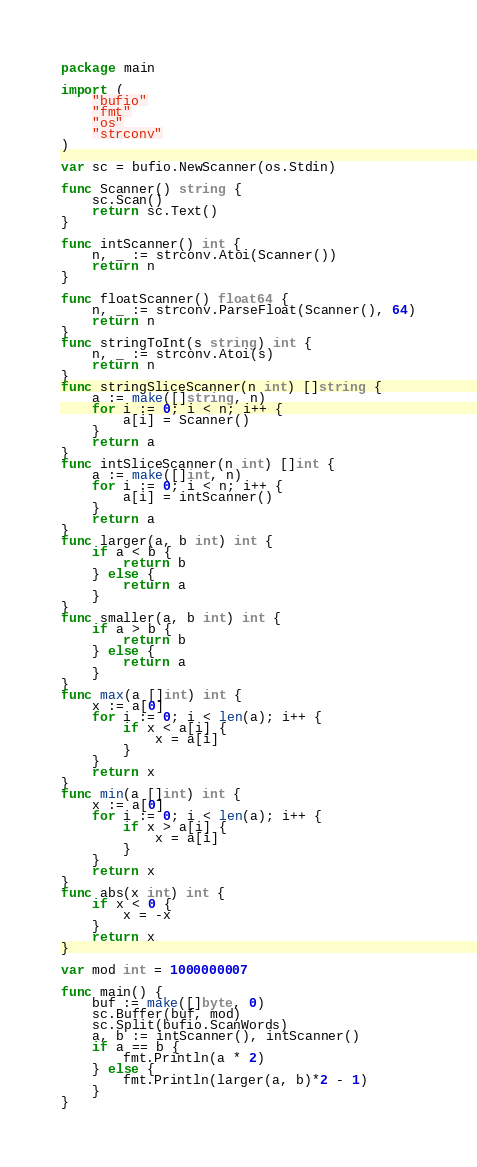<code> <loc_0><loc_0><loc_500><loc_500><_Go_>package main

import (
	"bufio"
	"fmt"
	"os"
	"strconv"
)

var sc = bufio.NewScanner(os.Stdin)

func Scanner() string {
	sc.Scan()
	return sc.Text()
}

func intScanner() int {
	n, _ := strconv.Atoi(Scanner())
	return n
}

func floatScanner() float64 {
	n, _ := strconv.ParseFloat(Scanner(), 64)
	return n
}
func stringToInt(s string) int {
	n, _ := strconv.Atoi(s)
	return n
}
func stringSliceScanner(n int) []string {
	a := make([]string, n)
	for i := 0; i < n; i++ {
		a[i] = Scanner()
	}
	return a
}
func intSliceScanner(n int) []int {
	a := make([]int, n)
	for i := 0; i < n; i++ {
		a[i] = intScanner()
	}
	return a
}
func larger(a, b int) int {
	if a < b {
		return b
	} else {
		return a
	}
}
func smaller(a, b int) int {
	if a > b {
		return b
	} else {
		return a
	}
}
func max(a []int) int {
	x := a[0]
	for i := 0; i < len(a); i++ {
		if x < a[i] {
			x = a[i]
		}
	}
	return x
}
func min(a []int) int {
	x := a[0]
	for i := 0; i < len(a); i++ {
		if x > a[i] {
			x = a[i]
		}
	}
	return x
}
func abs(x int) int {
	if x < 0 {
		x = -x
	}
	return x
}

var mod int = 1000000007

func main() {
	buf := make([]byte, 0)
	sc.Buffer(buf, mod)
	sc.Split(bufio.ScanWords)
	a, b := intScanner(), intScanner()
	if a == b {
		fmt.Println(a * 2)
	} else {
		fmt.Println(larger(a, b)*2 - 1)
	}
}
</code> 